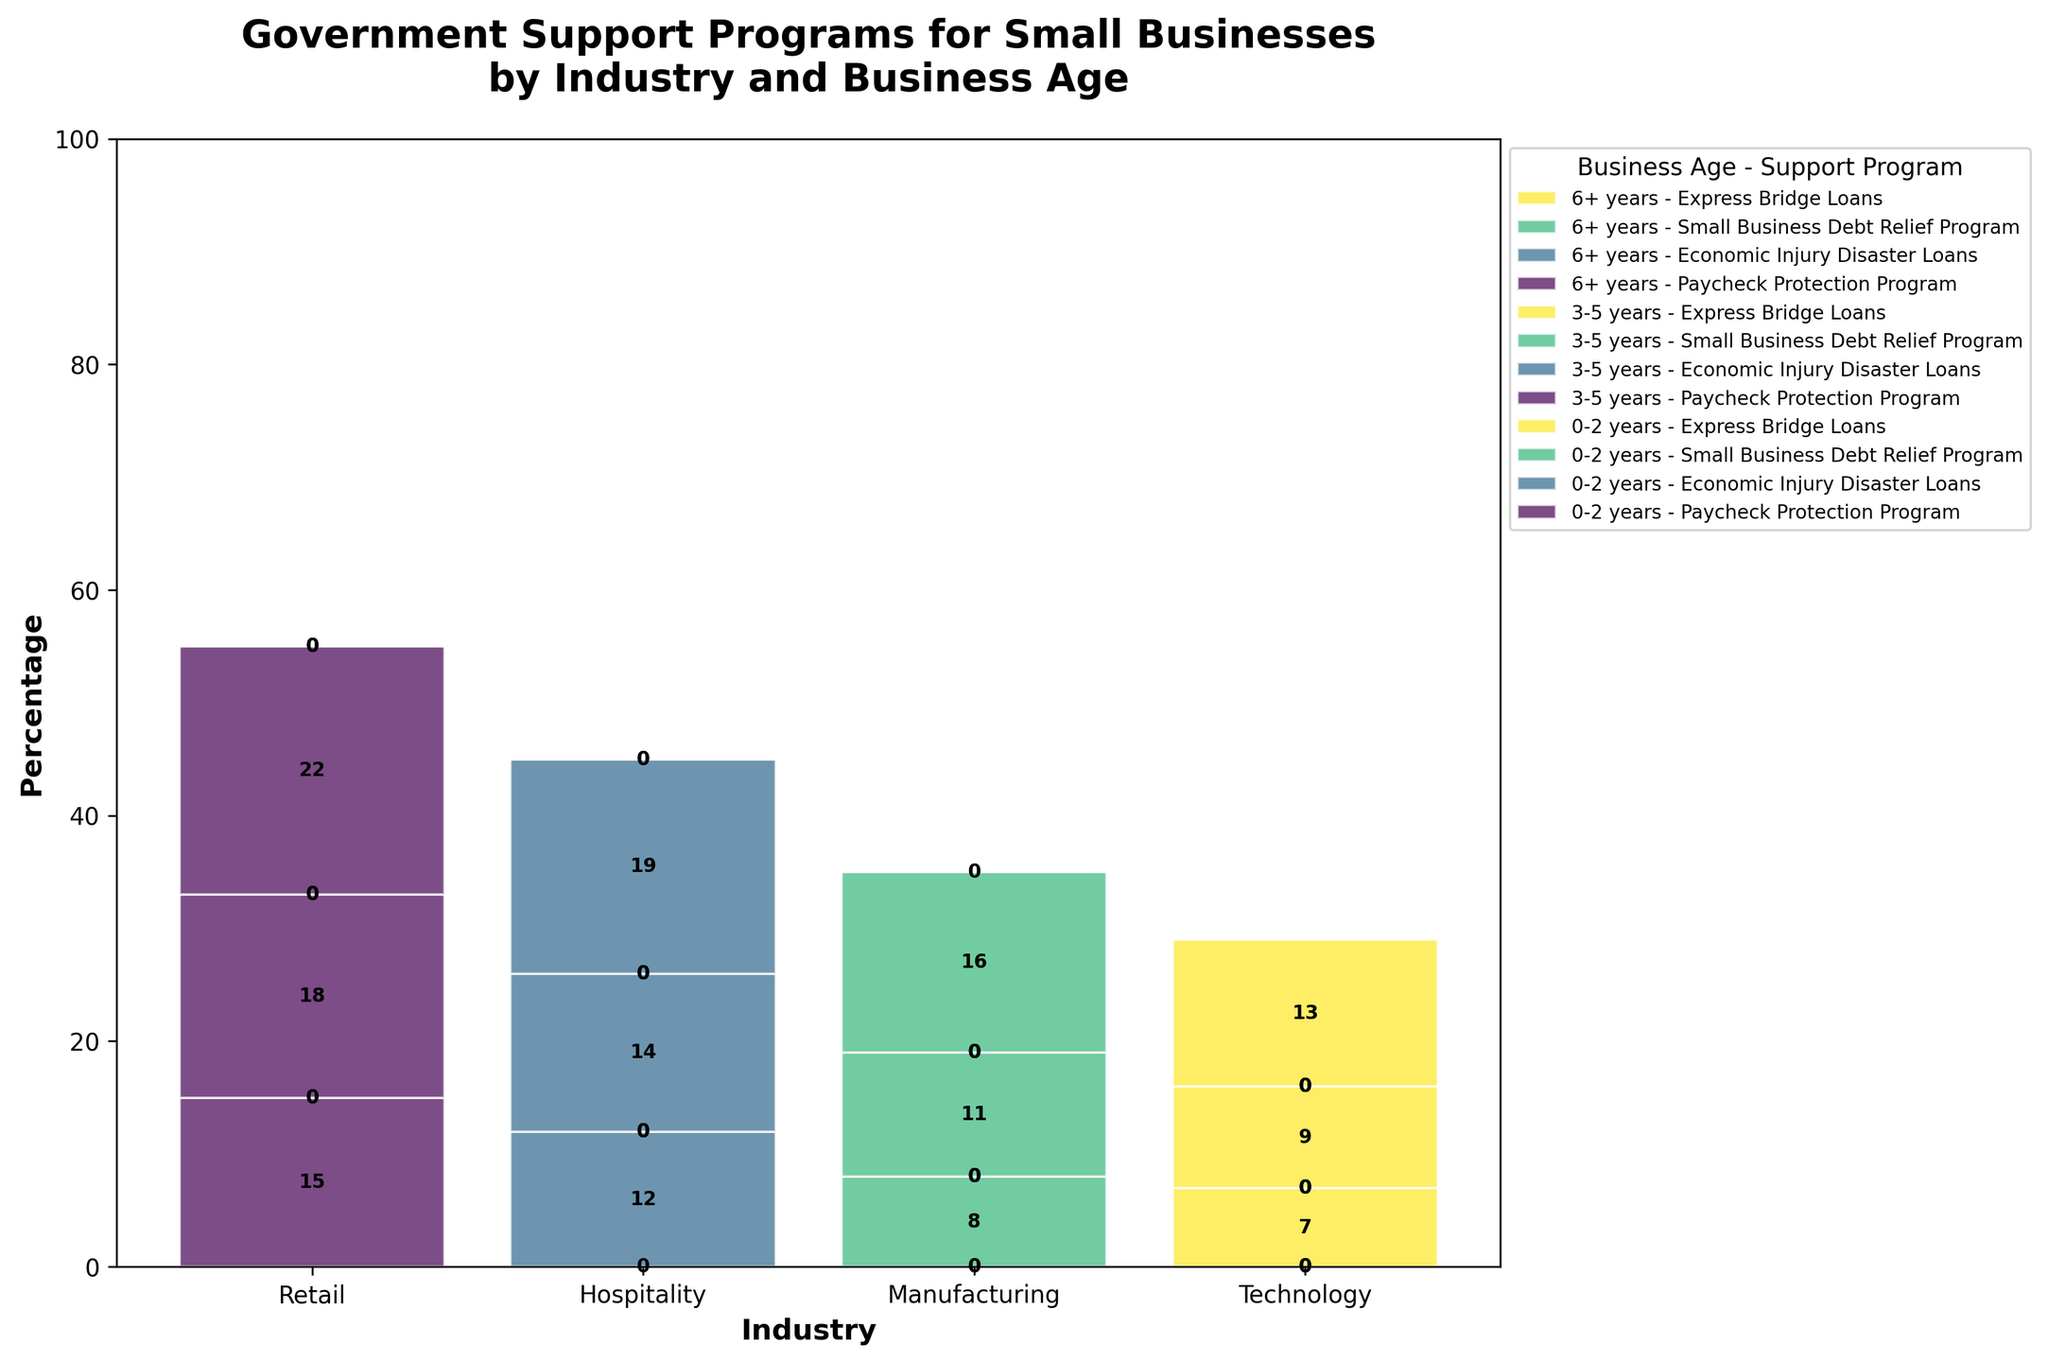What's the title of the figure? The title is usually the text found at the top of the plot. Here, it is placed prominently to summarize the overall content of the plot, which is the breakdown of government support programs for small businesses during economic downturns, split by industry and business age.
Answer: Government Support Programs for Small Businesses by Industry and Business Age Which industry has the highest percentage of support from the Paycheck Protection Program for businesses aged 6+ years? First, identify which bars represent the Paycheck Protection Program for businesses aged 6+ years, likely indicated by specific colors or labels in the legend. Then, compare the heights of these bars for all industries. The Retail industry's bar will be the tallest.
Answer: Retail For businesses aged 0-2 years in the Technology industry, what is the support program with the highest percentage? Locate the section of the plot for the Technology industry. Then, identify the bars representing businesses aged 0-2 years. Among these bars, find the highest one. The legend confirms this bar corresponds to Express Bridge Loans.
Answer: Express Bridge Loans Compare the percentage of support from Economic Injury Disaster Loans for businesses aged 3-5 years between the Hospitality and Retail industries. Which industry receives more, and by how much? Locate the data points representing Economic Injury Disaster Loans for businesses aged 3-5 years for both Hospitality and Retail industries by checking appropriate sections and colors in the plot. Hospitality receives 14%, and Retail is not listed under this program for these ages, meaning its contribution is 0%. The difference is therefore 14%.
Answer: Hospitality by 14% What is the combined percentage of support from the Small Business Debt Relief Program across all business ages in the Manufacturing industry? Identify the bars for the Small Business Debt Relief Program in the Manufacturing industry. Gather their heights for each business age group (0-2 years: 8%, 3-5 years: 11%, 6+ years: 16%) and sum them (8 + 11 + 16).
Answer: 35% Which support program is least represented in the Retail industry? In the Retail industry section, identify the bars representing each support program by their labels/colors. The program with the smallest bar(s) is the least represented. This is not explicitly present in the data, so it must be inferred as another program like Express Bridge Loans which is not mentioned.
Answer: Express Bridge Loans (inferred) By how much does the percentage of support from the Paycheck Protection Program for businesses aged 3-5 years in Retail surpass the support for the same age group in Manufacturing? Locate the bars representing the Paycheck Protection Program for Retail and Manufacturing (aged 3-5 years). For Retail, it's 18%, while Manufacturing is zero indicated as not listed. The calculation will show 18 - 0.
Answer: 18% Which industry has the most even distribution of support programs across different business ages? Compare the heights of bars for each industry, considering how balanced they appear across different age groups and programs. In the plot, Manufacturing shows more consistent variation across age groups and support types.
Answer: Manufacturing 